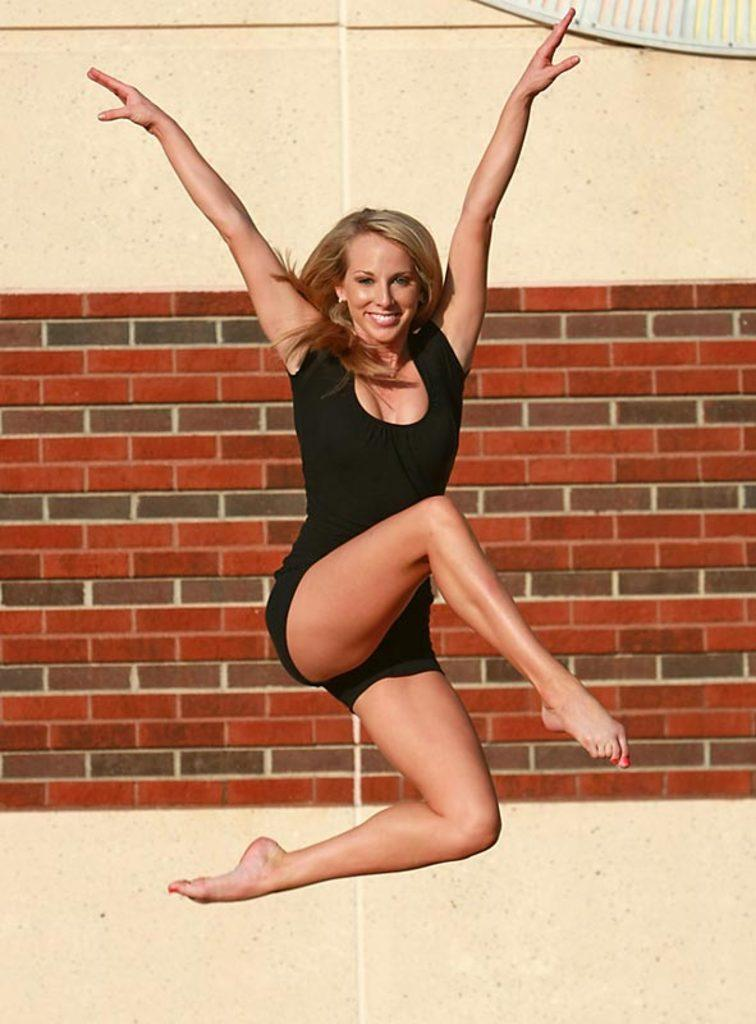Who is present in the image? There is a woman in the image. What is the woman wearing? The woman is wearing a black dress. What is the woman's facial expression? The woman is smiling. What can be seen on the wall in the image? Red color bricks are visible on the wall. What does the woman regret in the image? There is no indication in the image that the woman is experiencing regret, as her facial expression is a smile. 